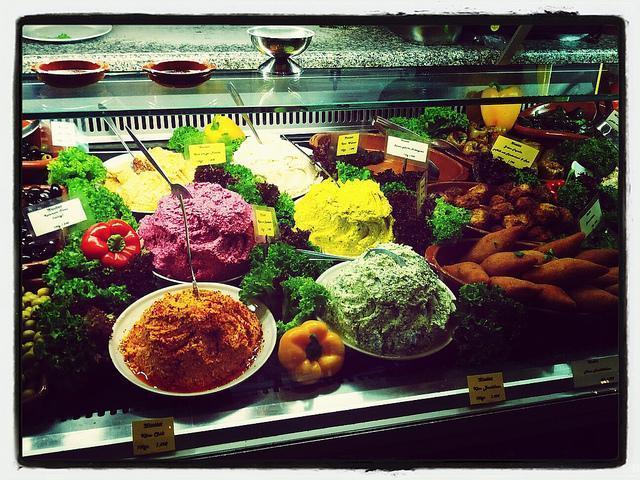How many bowls are there?
Give a very brief answer. 5. How many cars have zebra stripes?
Give a very brief answer. 0. 